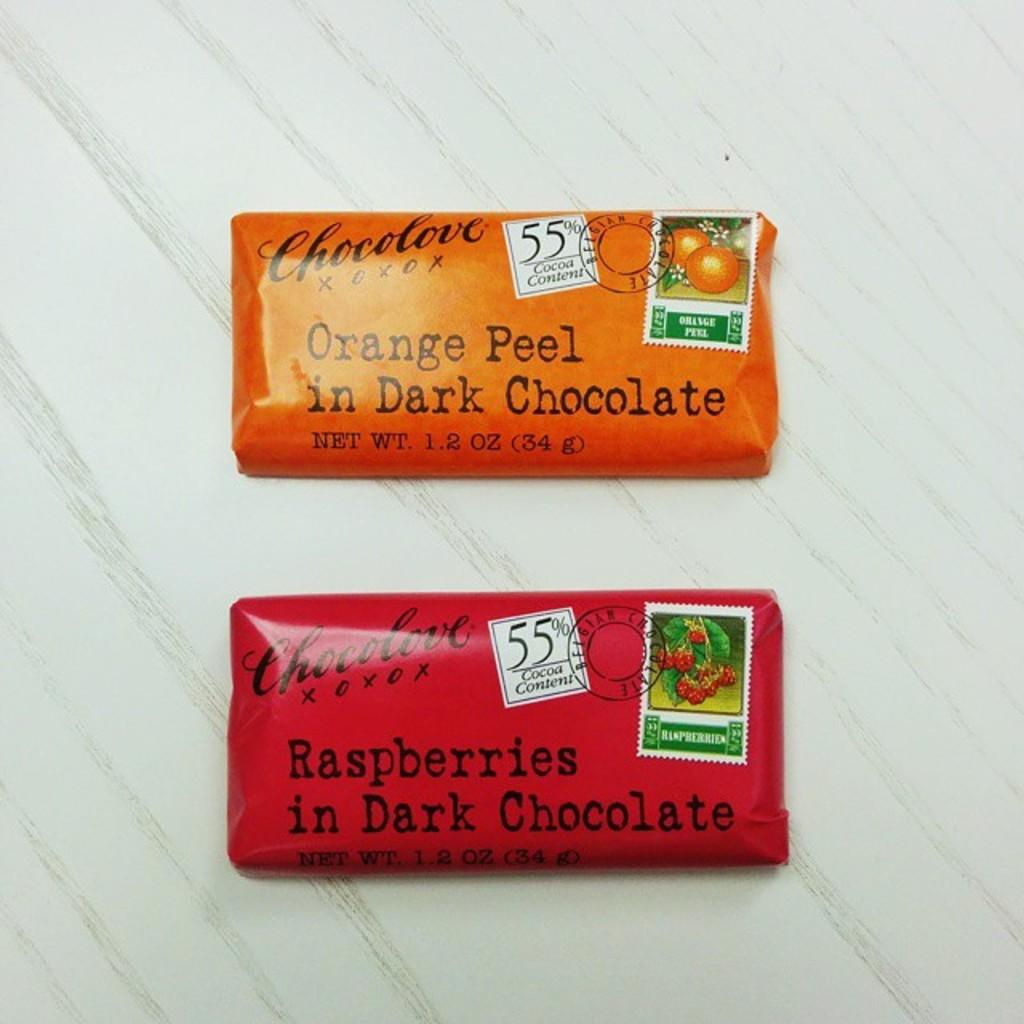<image>
Write a terse but informative summary of the picture. Two chocolate bars, one of them orange peel flavored, sit on a table. 